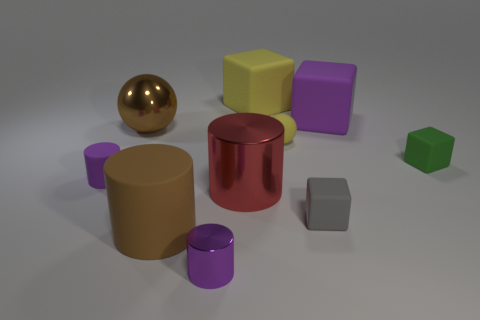Subtract all big shiny cylinders. How many cylinders are left? 3 Subtract all red spheres. How many purple cylinders are left? 2 Subtract all red cylinders. How many cylinders are left? 3 Subtract all balls. How many objects are left? 8 Add 5 yellow balls. How many yellow balls exist? 6 Subtract 0 cyan cubes. How many objects are left? 10 Subtract all yellow blocks. Subtract all yellow balls. How many blocks are left? 3 Subtract all large blue matte balls. Subtract all large purple objects. How many objects are left? 9 Add 2 small purple matte things. How many small purple matte things are left? 3 